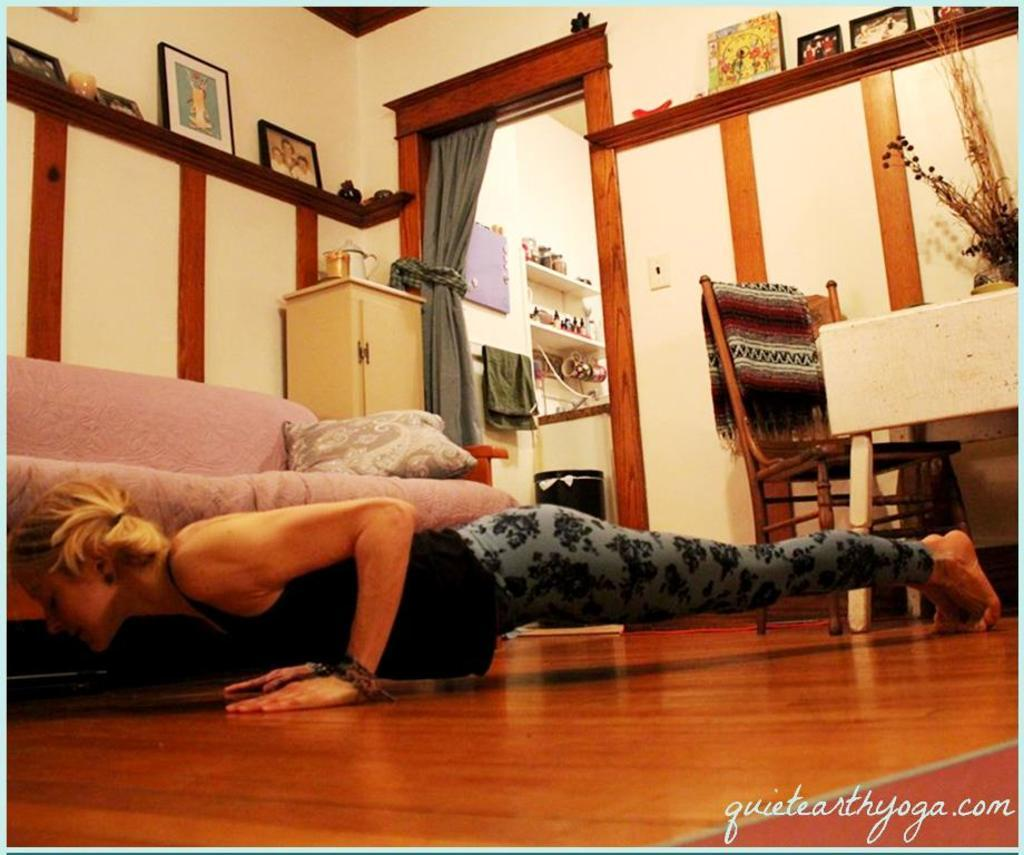Who is the person in the image? There is a woman in the image. What is the woman doing in the image? The woman is doing exercise in the image. What is the woman's position in the image? The woman is on the floor in the image. What furniture can be seen in the image? There is a sofa and a chair in the image. What type of bridge can be seen in the image? There is no bridge present in the image. How many fangs does the woman have in the image? The woman does not have any fangs in the image. 